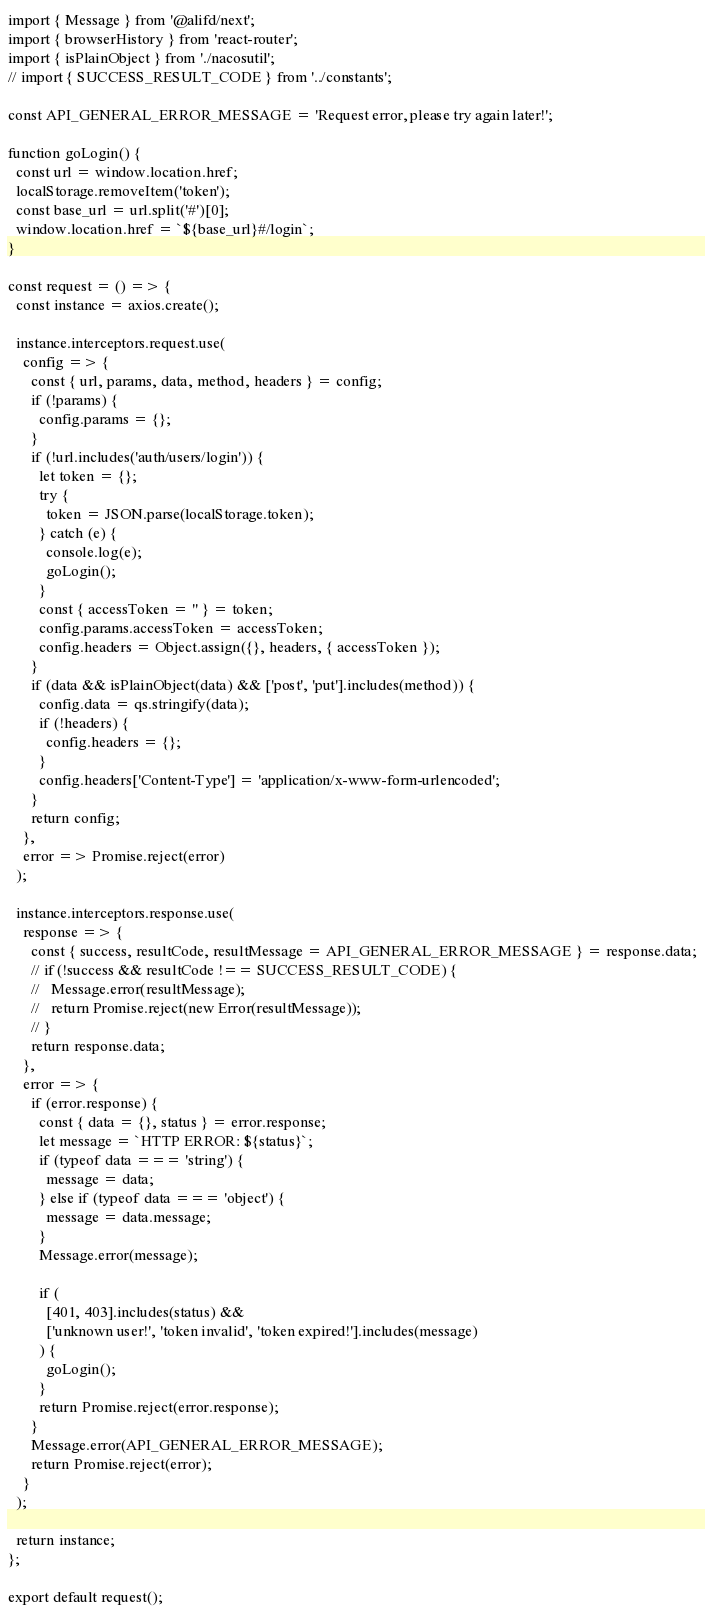<code> <loc_0><loc_0><loc_500><loc_500><_JavaScript_>import { Message } from '@alifd/next';
import { browserHistory } from 'react-router';
import { isPlainObject } from './nacosutil';
// import { SUCCESS_RESULT_CODE } from '../constants';

const API_GENERAL_ERROR_MESSAGE = 'Request error, please try again later!';

function goLogin() {
  const url = window.location.href;
  localStorage.removeItem('token');
  const base_url = url.split('#')[0];
  window.location.href = `${base_url}#/login`;
}

const request = () => {
  const instance = axios.create();

  instance.interceptors.request.use(
    config => {
      const { url, params, data, method, headers } = config;
      if (!params) {
        config.params = {};
      }
      if (!url.includes('auth/users/login')) {
        let token = {};
        try {
          token = JSON.parse(localStorage.token);
        } catch (e) {
          console.log(e);
          goLogin();
        }
        const { accessToken = '' } = token;
        config.params.accessToken = accessToken;
        config.headers = Object.assign({}, headers, { accessToken });
      }
      if (data && isPlainObject(data) && ['post', 'put'].includes(method)) {
        config.data = qs.stringify(data);
        if (!headers) {
          config.headers = {};
        }
        config.headers['Content-Type'] = 'application/x-www-form-urlencoded';
      }
      return config;
    },
    error => Promise.reject(error)
  );

  instance.interceptors.response.use(
    response => {
      const { success, resultCode, resultMessage = API_GENERAL_ERROR_MESSAGE } = response.data;
      // if (!success && resultCode !== SUCCESS_RESULT_CODE) {
      //   Message.error(resultMessage);
      //   return Promise.reject(new Error(resultMessage));
      // }
      return response.data;
    },
    error => {
      if (error.response) {
        const { data = {}, status } = error.response;
        let message = `HTTP ERROR: ${status}`;
        if (typeof data === 'string') {
          message = data;
        } else if (typeof data === 'object') {
          message = data.message;
        }
        Message.error(message);

        if (
          [401, 403].includes(status) &&
          ['unknown user!', 'token invalid', 'token expired!'].includes(message)
        ) {
          goLogin();
        }
        return Promise.reject(error.response);
      }
      Message.error(API_GENERAL_ERROR_MESSAGE);
      return Promise.reject(error);
    }
  );

  return instance;
};

export default request();
</code> 